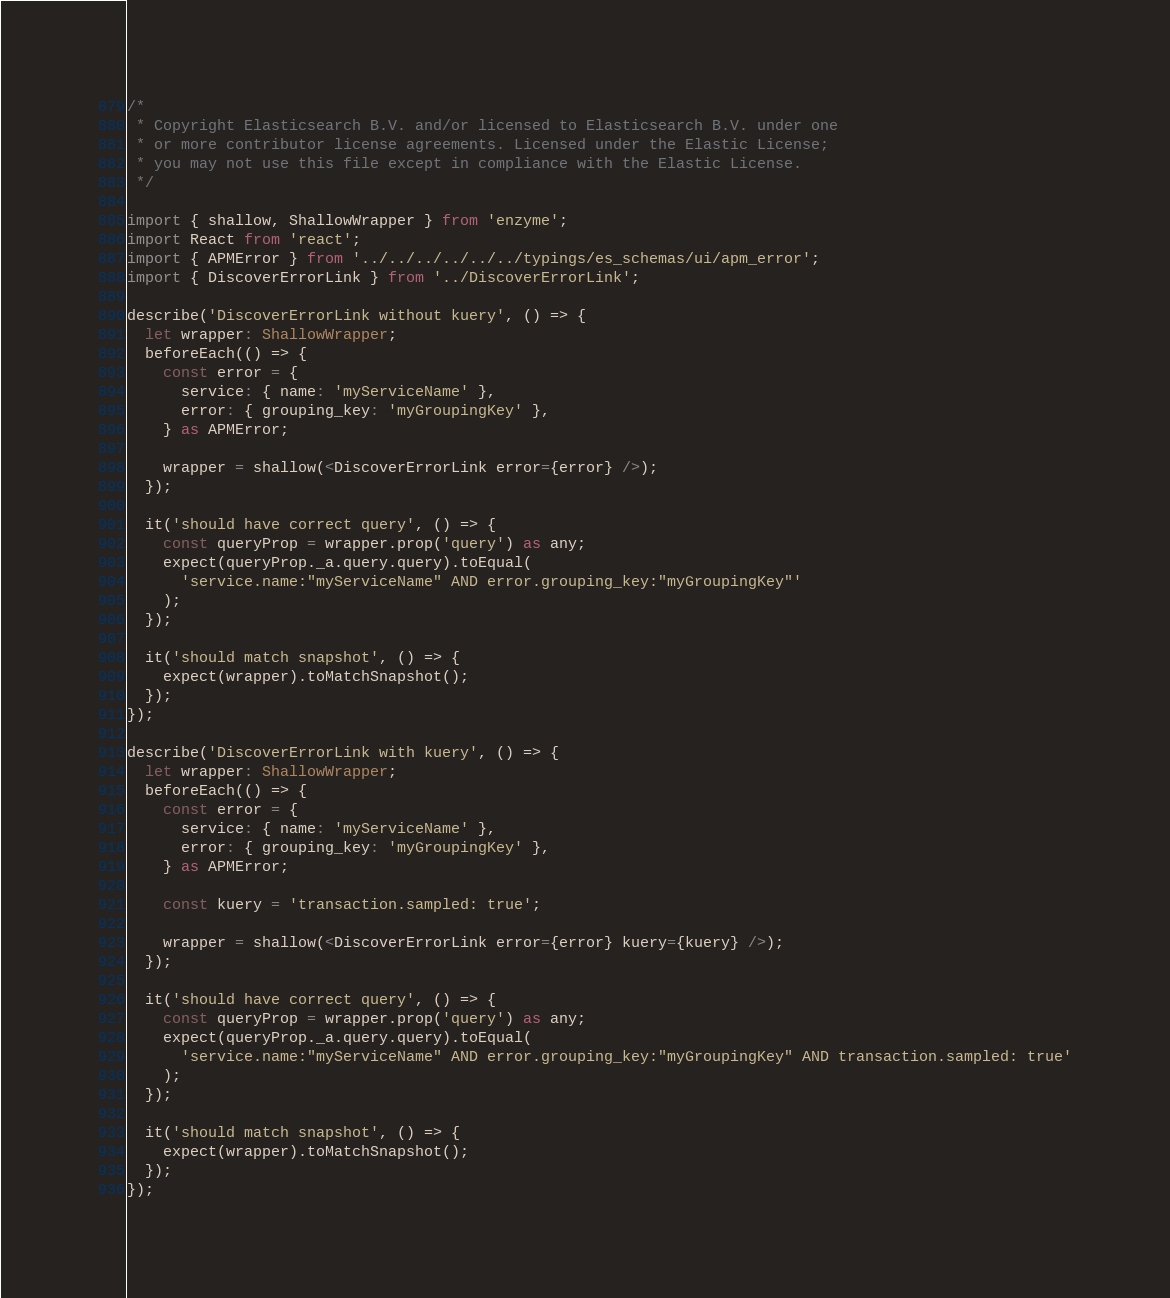Convert code to text. <code><loc_0><loc_0><loc_500><loc_500><_TypeScript_>/*
 * Copyright Elasticsearch B.V. and/or licensed to Elasticsearch B.V. under one
 * or more contributor license agreements. Licensed under the Elastic License;
 * you may not use this file except in compliance with the Elastic License.
 */

import { shallow, ShallowWrapper } from 'enzyme';
import React from 'react';
import { APMError } from '../../../../../../typings/es_schemas/ui/apm_error';
import { DiscoverErrorLink } from '../DiscoverErrorLink';

describe('DiscoverErrorLink without kuery', () => {
  let wrapper: ShallowWrapper;
  beforeEach(() => {
    const error = {
      service: { name: 'myServiceName' },
      error: { grouping_key: 'myGroupingKey' },
    } as APMError;

    wrapper = shallow(<DiscoverErrorLink error={error} />);
  });

  it('should have correct query', () => {
    const queryProp = wrapper.prop('query') as any;
    expect(queryProp._a.query.query).toEqual(
      'service.name:"myServiceName" AND error.grouping_key:"myGroupingKey"'
    );
  });

  it('should match snapshot', () => {
    expect(wrapper).toMatchSnapshot();
  });
});

describe('DiscoverErrorLink with kuery', () => {
  let wrapper: ShallowWrapper;
  beforeEach(() => {
    const error = {
      service: { name: 'myServiceName' },
      error: { grouping_key: 'myGroupingKey' },
    } as APMError;

    const kuery = 'transaction.sampled: true';

    wrapper = shallow(<DiscoverErrorLink error={error} kuery={kuery} />);
  });

  it('should have correct query', () => {
    const queryProp = wrapper.prop('query') as any;
    expect(queryProp._a.query.query).toEqual(
      'service.name:"myServiceName" AND error.grouping_key:"myGroupingKey" AND transaction.sampled: true'
    );
  });

  it('should match snapshot', () => {
    expect(wrapper).toMatchSnapshot();
  });
});
</code> 